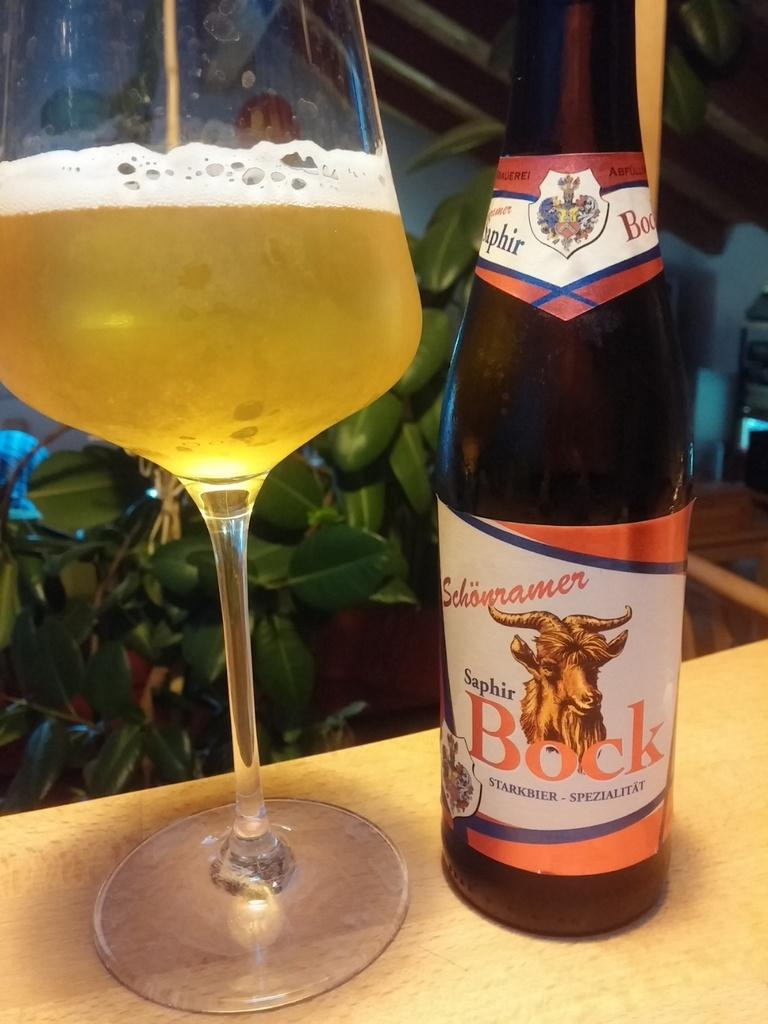<image>
Create a compact narrative representing the image presented. A bottle of Bock is next to a glass. 